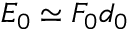Convert formula to latex. <formula><loc_0><loc_0><loc_500><loc_500>E _ { 0 } \simeq F _ { 0 } d _ { 0 }</formula> 